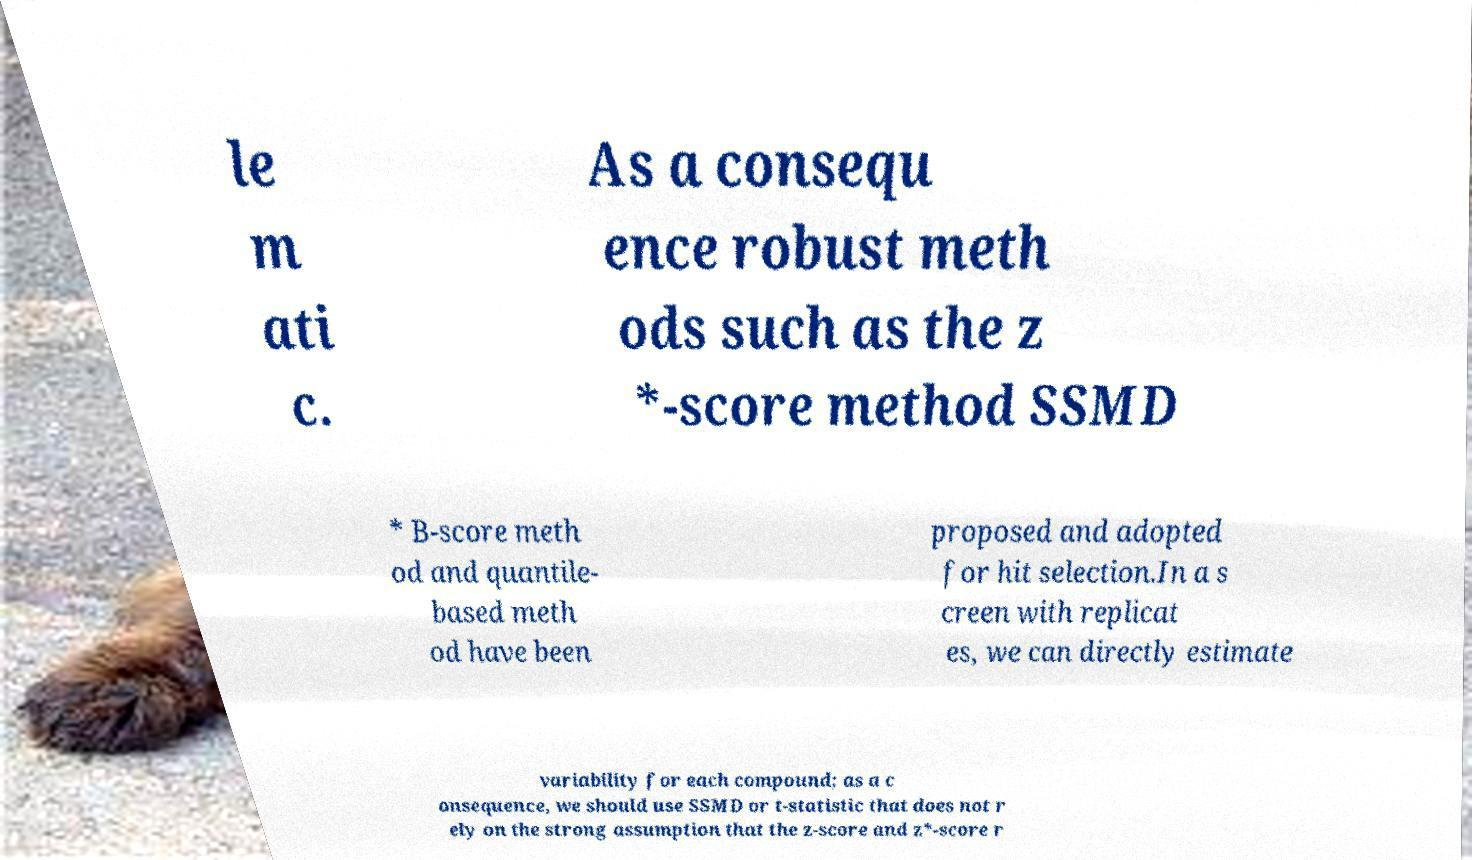Please read and relay the text visible in this image. What does it say? le m ati c. As a consequ ence robust meth ods such as the z *-score method SSMD * B-score meth od and quantile- based meth od have been proposed and adopted for hit selection.In a s creen with replicat es, we can directly estimate variability for each compound; as a c onsequence, we should use SSMD or t-statistic that does not r ely on the strong assumption that the z-score and z*-score r 